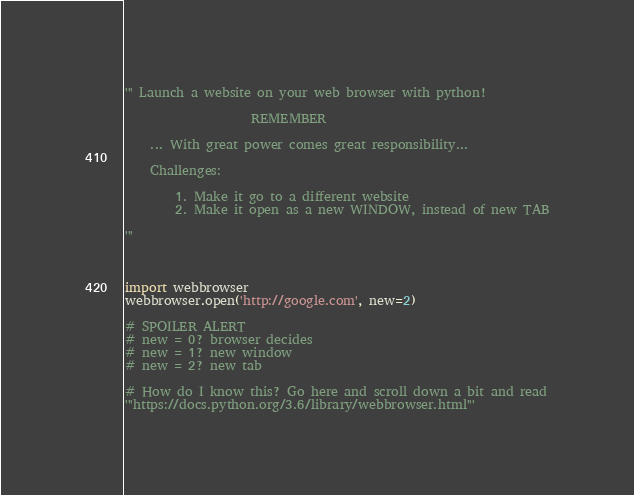<code> <loc_0><loc_0><loc_500><loc_500><_Python_>''' Launch a website on your web browser with python!

                    REMEMBER

    ... With great power comes great responsibility...

    Challenges:

        1. Make it go to a different website
        2. Make it open as a new WINDOW, instead of new TAB

'''



import webbrowser
webbrowser.open('http://google.com', new=2)

# SPOILER ALERT
# new = 0? browser decides
# new = 1? new window
# new = 2? new tab

# How do I know this? Go here and scroll down a bit and read
'''https://docs.python.org/3.6/library/webbrowser.html'''
</code> 